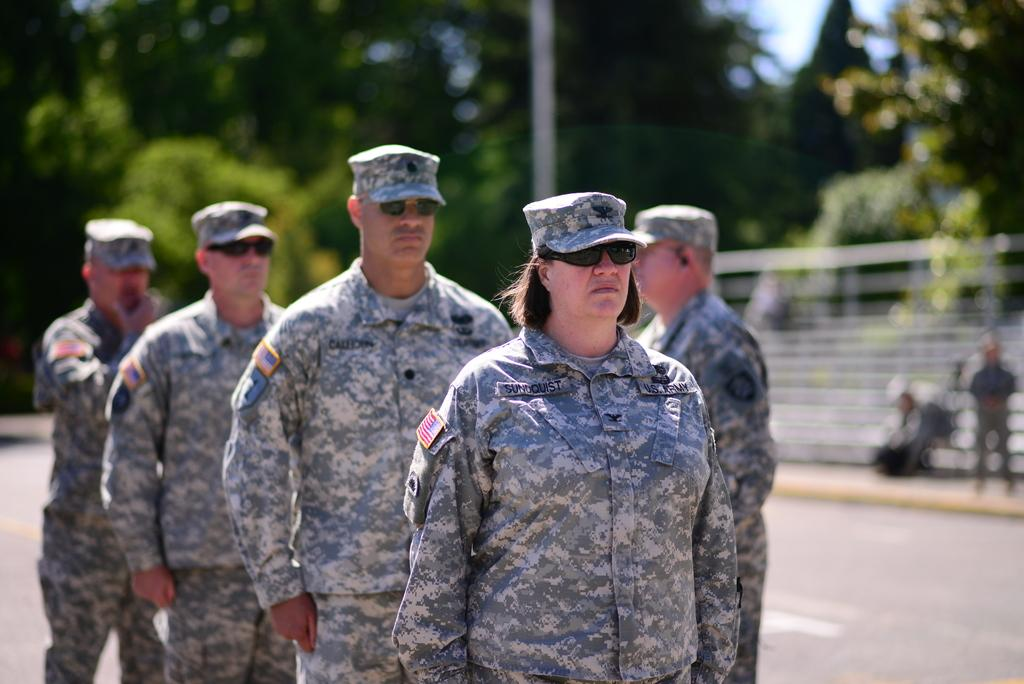What are the main subjects in the image? There are soldiers standing on a road in the image. What can be seen in the distance behind the soldiers? There are trees visible in the background of the image. How would you describe the appearance of the background? The background appears blurred. How many trucks are parked next to the soldiers in the image? There are no trucks visible in the image; it only shows soldiers standing on a road with trees in the background. 